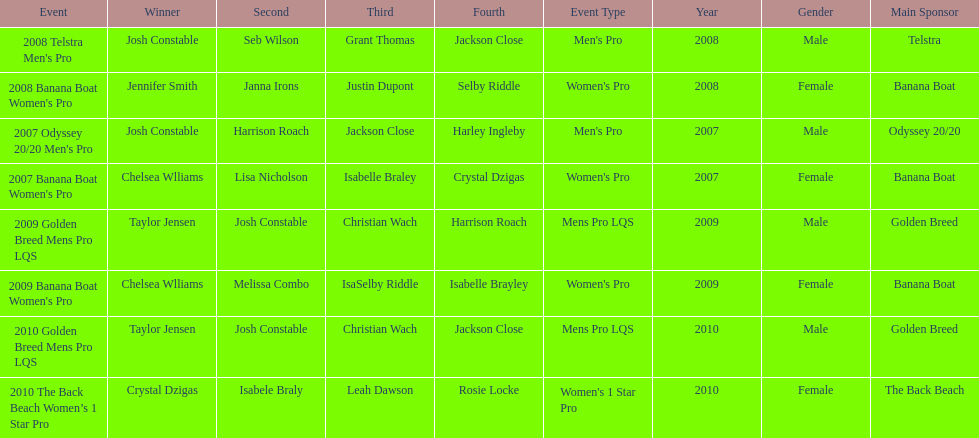In what two races did chelsea williams earn the same rank? 2007 Banana Boat Women's Pro, 2009 Banana Boat Women's Pro. 